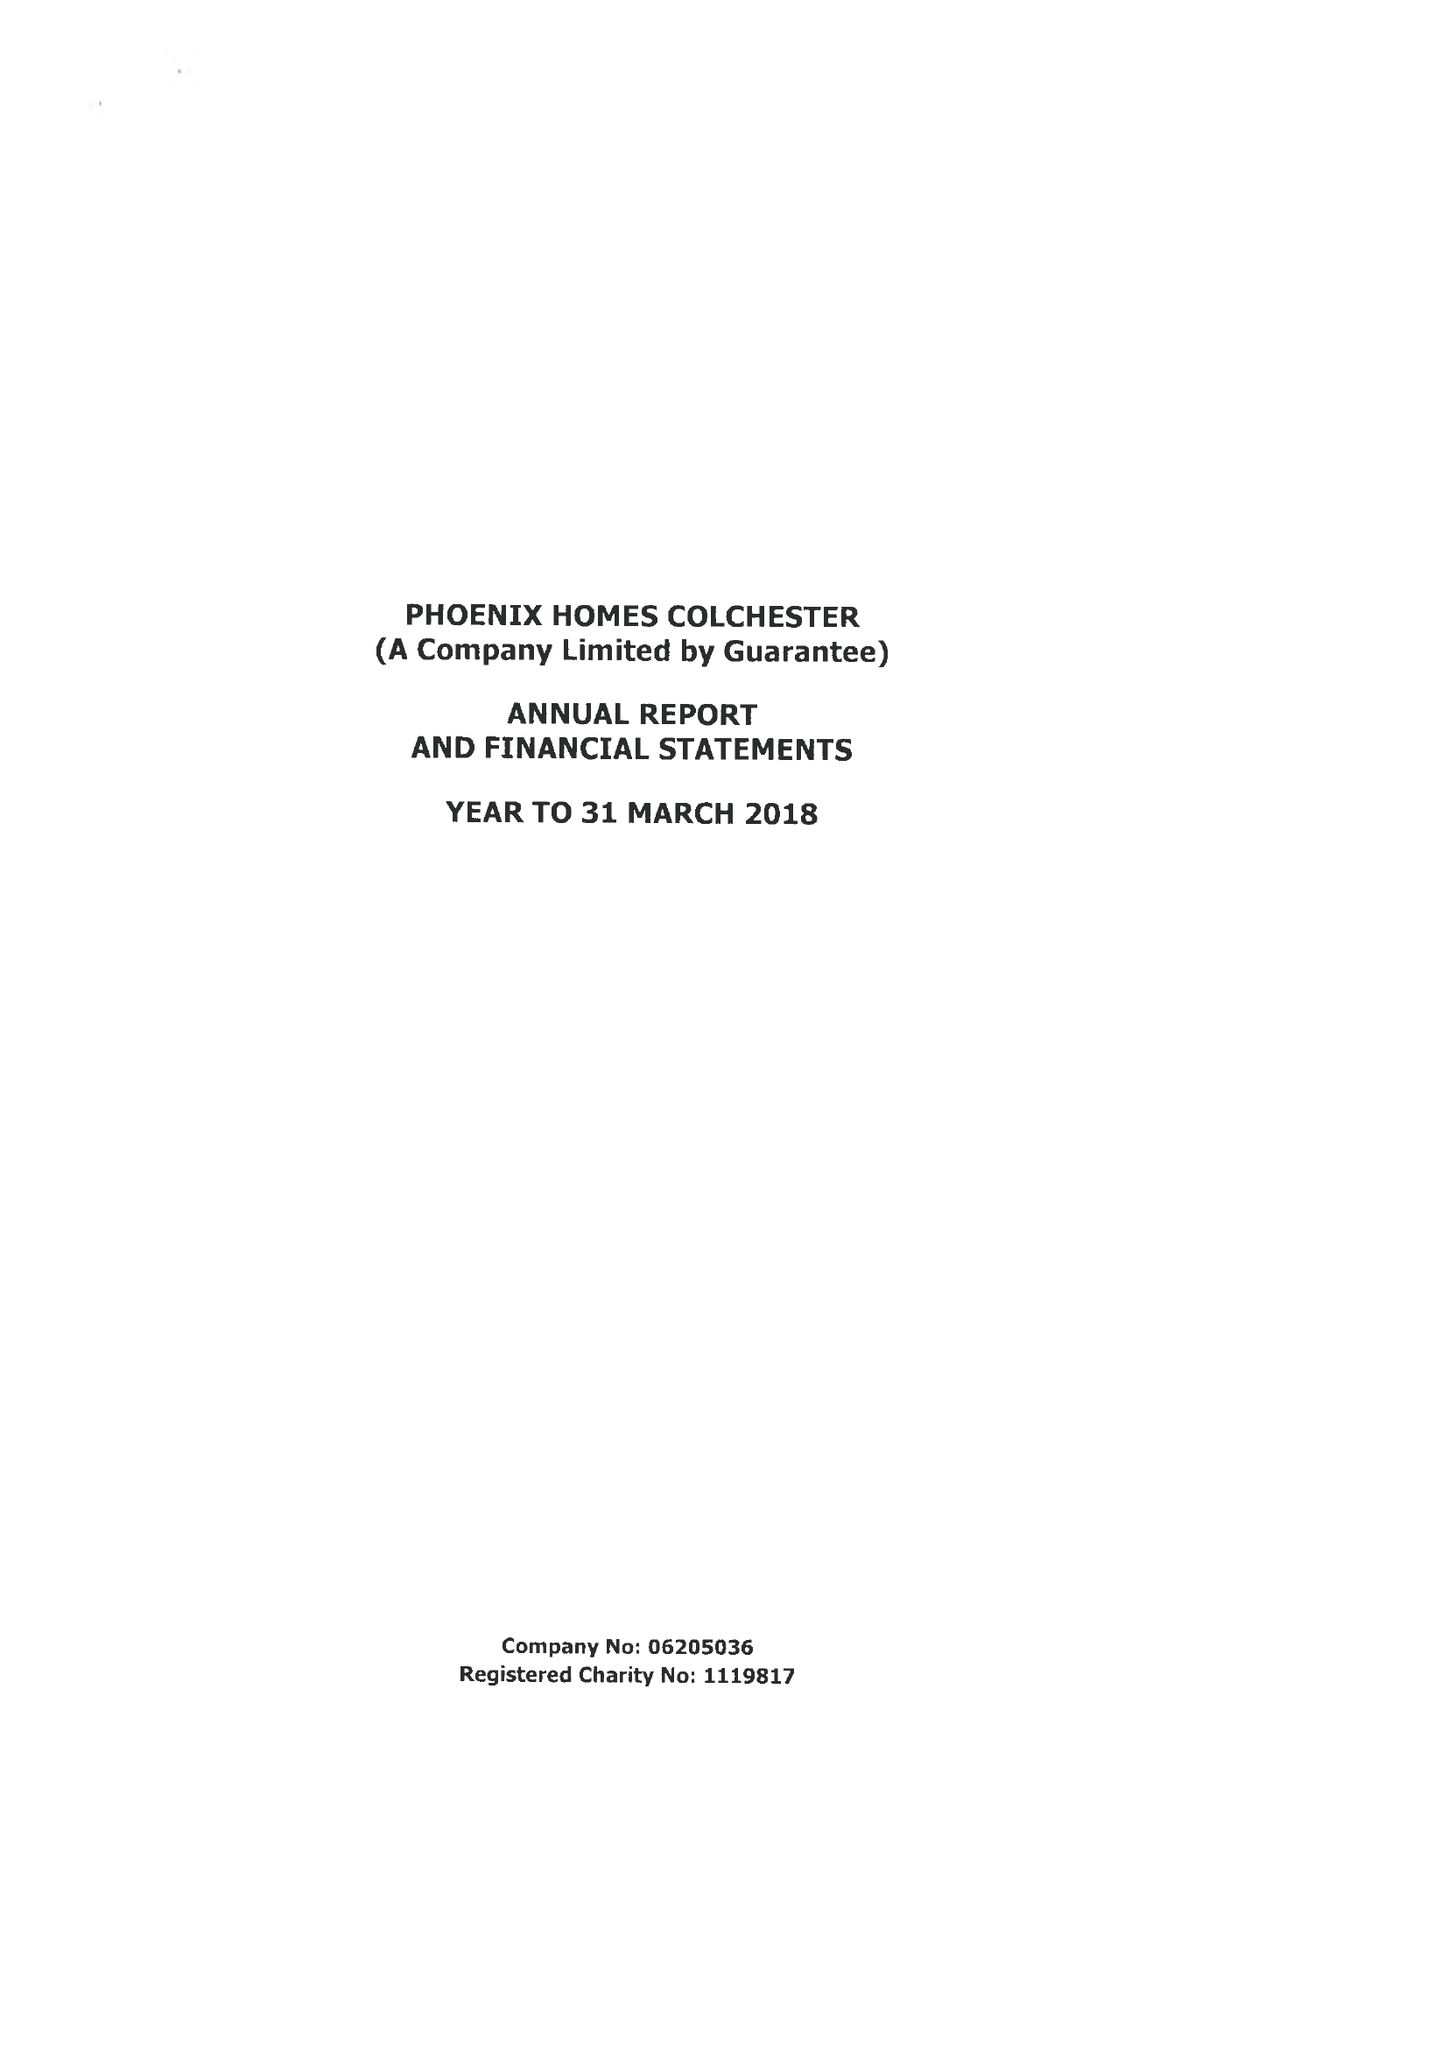What is the value for the address__postcode?
Answer the question using a single word or phrase. CO3 9DE 